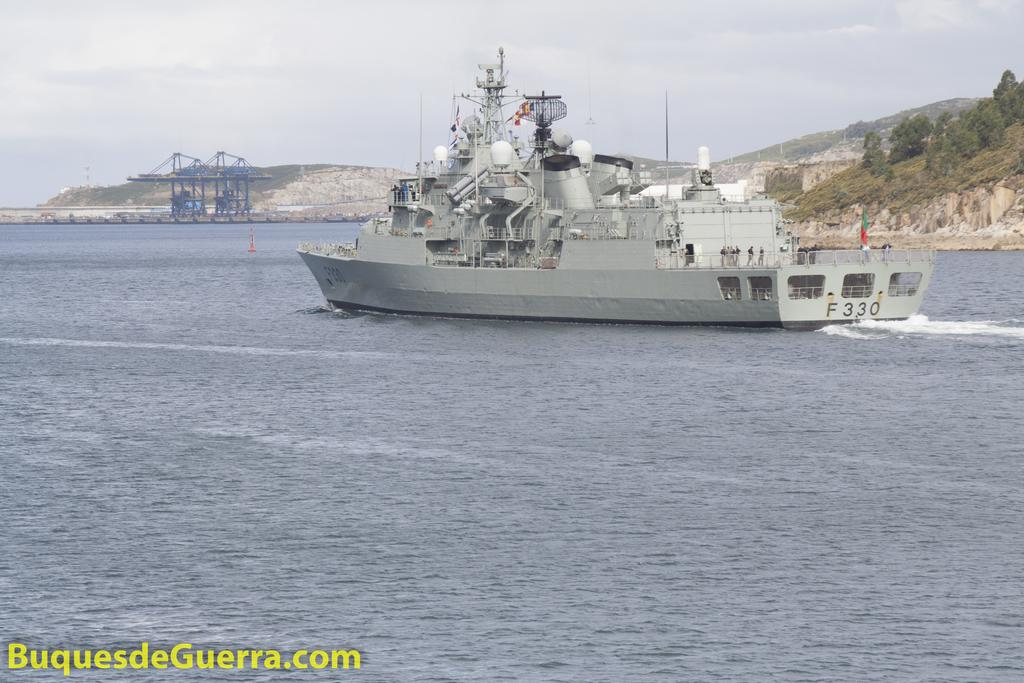<image>
Summarize the visual content of the image. A military ship shown in a body of water over top of the cation BuquesdeGuerra.com. 